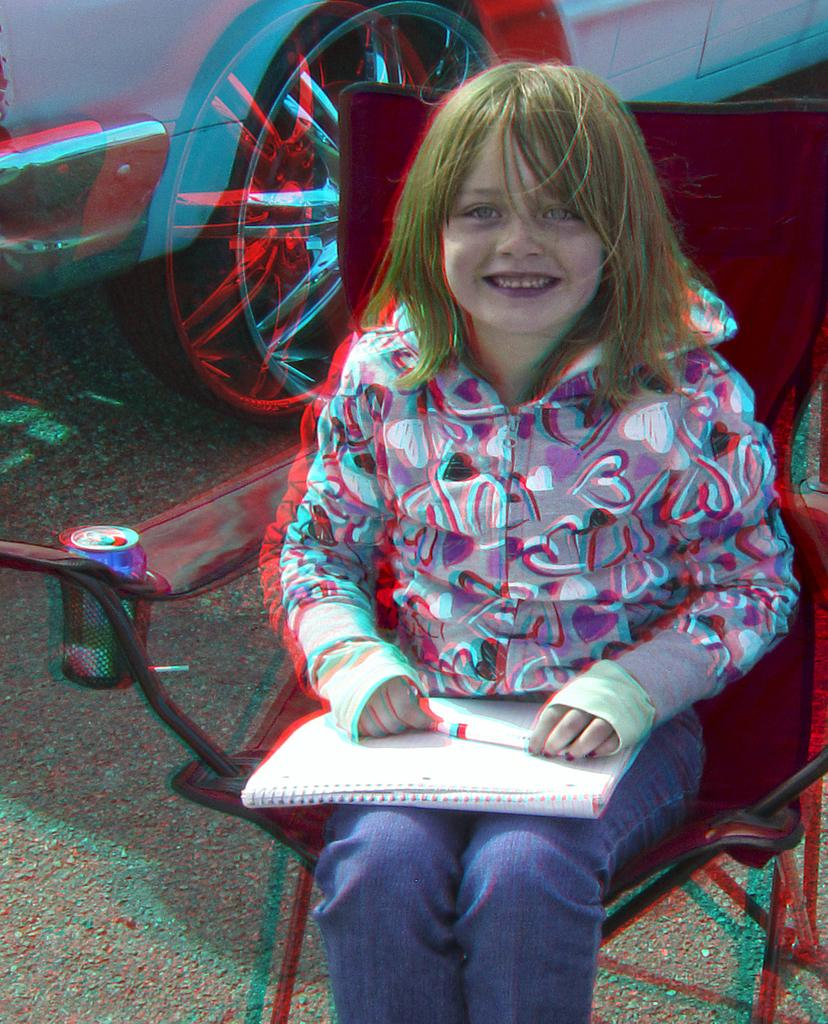Who is the main subject in the image? There is a girl in the image. What is the girl doing in the image? The girl is sitting on a chair. What items does the girl have on her lap? The girl has a book and a pen on her lap. What can be seen in the background of the image? There is a car visible on the road in the background of the image. What type of toothbrush is the girl using in the image? There is no toothbrush present in the image. What kind of produce can be seen on the girl's lap? There is no produce visible on the girl's lap; she has a book and a pen. 